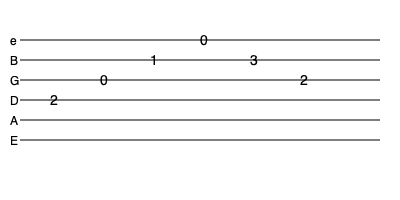What is the sequence of notes played in this guitar tablature, starting from the lowest pitch to the highest? To read this tablature and determine the sequence of notes from lowest to highest pitch, let's follow these steps:

1. Identify the string and fret for each note:
   - First note: D string (4th string), 2nd fret
   - Second note: G string (3rd string), open (0)
   - Third note: B string (2nd string), 1st fret
   - Fourth note: High E string (1st string), open (0)
   - Fifth note: B string (2nd string), 3rd fret
   - Sixth note: G string (3rd string), 2nd fret

2. Determine the actual notes:
   - D string, 2nd fret = E
   - G string, open = G
   - B string, 1st fret = C
   - High E string, open = E
   - B string, 3rd fret = D
   - G string, 2nd fret = A

3. Arrange the notes from lowest to highest pitch:
   E (on D string) < G < A < C < D < E (on high E string)

Therefore, the sequence of notes from lowest to highest pitch is: E, G, A, C, D, E.
Answer: E, G, A, C, D, E 